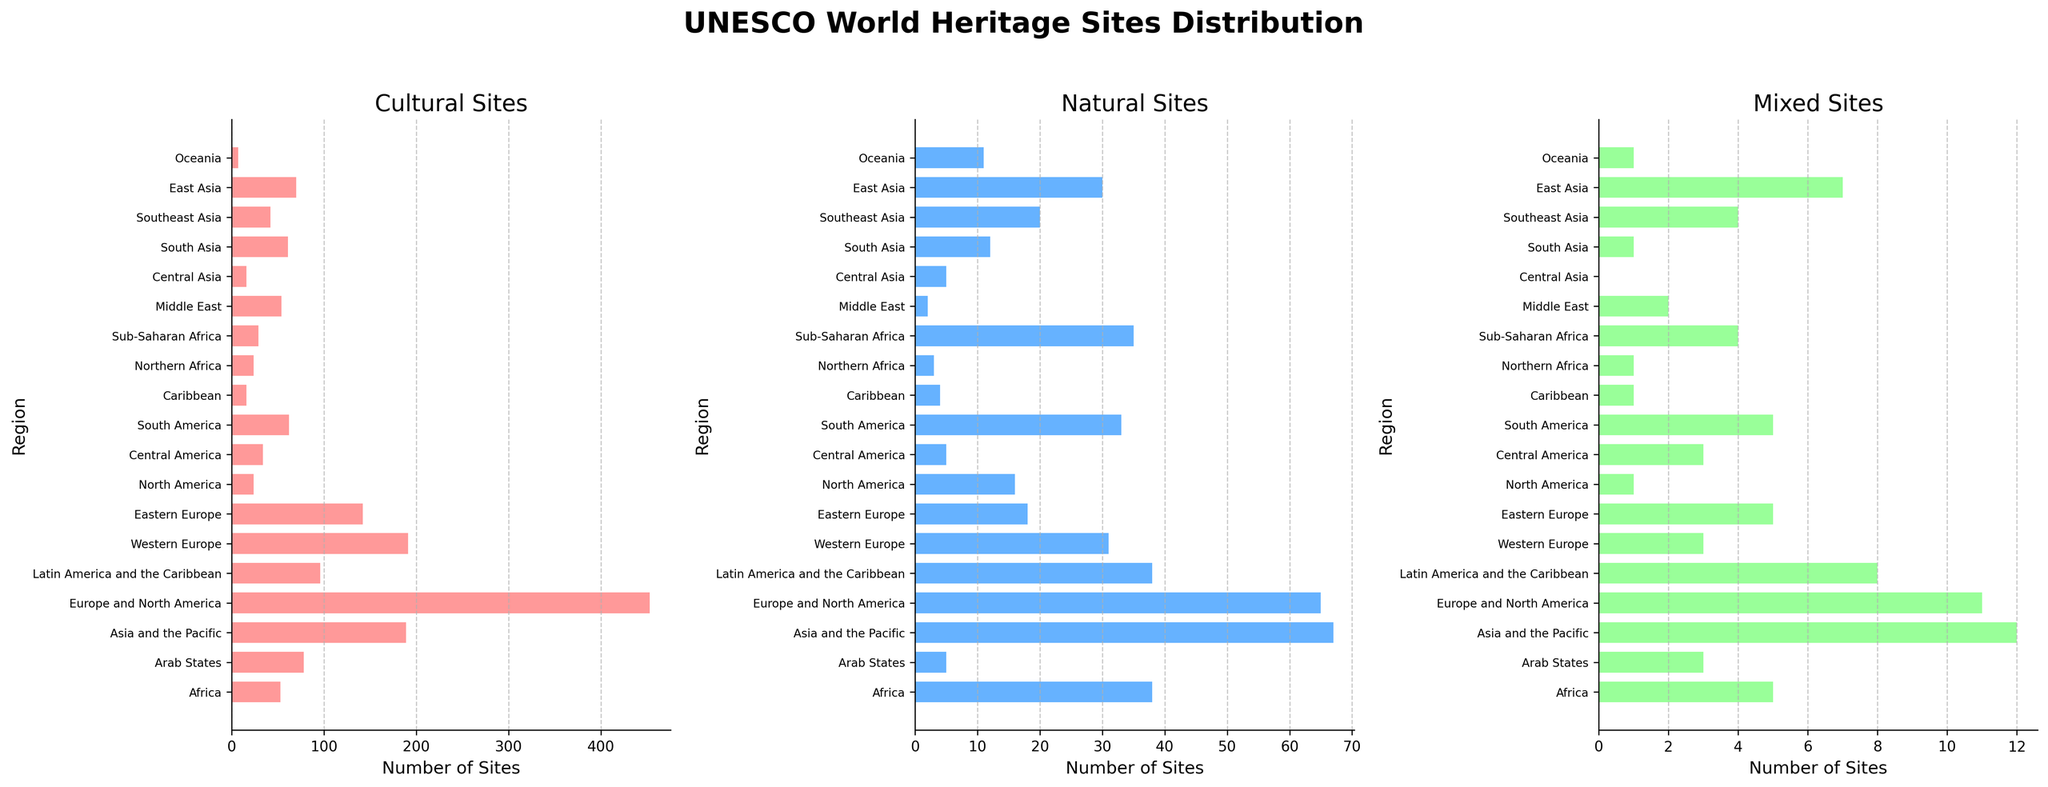Which region has the highest number of Cultural Sites? Refer to the "Cultural Sites" subplot. The region with the longest bar in the "Cultural Sites" subplot is Europe and North America with 453 sites.
Answer: Europe and North America What is the ratio of Cultural to Natural Sites in Asia and the Pacific? Look at the bars for "Asia and the Pacific" in both Cultural and Natural Sites subplots. Cultural Sites = 189, Natural Sites = 67. The ratio is 189 divided by 67.
Answer: 189:67 What is the total number of Mixed Sites in all regions combined? Sum the lengths of the bars in the "Mixed Sites" subplot. The lengths represent the number of sites respectively. Add all the given numbers together: 5+3+12+11+8+3+5+1+3+5+1+1+4+2+0+1+4+7+1 = 79.
Answer: 79 Which region has more Natural Sites, Sub-Saharan Africa or Latin America and the Caribbean? Compare the lengths of the bars in the "Natural Sites" subplot for Sub-Saharan Africa (35) and Latin America and the Caribbean (38). 38 is greater than 35.
Answer: Latin America and the Caribbean Does any region have an equal number of Cultural and Natural Sites? Look at all bars in Cultural and Natural Sites subplots to compare. Only Western Europe has 31 Cultural Sites and 31 Natural Sites.
Answer: Western Europe Combine the total number of Cultural and Natural Sites for South Asia. What is their sum? Look at the bars for "South Asia" in both Cultural (61) and Natural Sites (12) subplots. The sum is 61 + 12 = 73.
Answer: 73 Which region has the highest number of Mixed Sites, and how many are there? Look at the "Mixed Sites" subplot. The region with the longest bar is Asia and the Pacific with 12 sites.
Answer: Asia and the Pacific, 12 By how much do Cultural Sites in East Asia exceed Natural Sites in the same region? Compare the lengths of the bars in Cultural (70) and Natural Sites (30) subplots for East Asia. The difference is 70 - 30 = 40.
Answer: 40 What proportion of Natural Sites in North America are there compared to Cultural Sites in the same region? Compare the lengths of the bars in Cultural (24) and Natural Sites (16) subplots for North America. The proportion is 16 out of 24, which is 16/24 = 2/3.
Answer: 2/3 